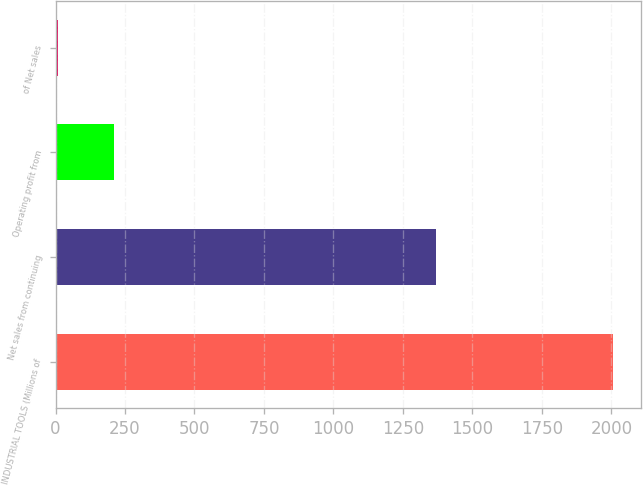Convert chart. <chart><loc_0><loc_0><loc_500><loc_500><bar_chart><fcel>INDUSTRIAL TOOLS (Millions of<fcel>Net sales from continuing<fcel>Operating profit from<fcel>of Net sales<nl><fcel>2005<fcel>1370<fcel>209.41<fcel>9.9<nl></chart> 